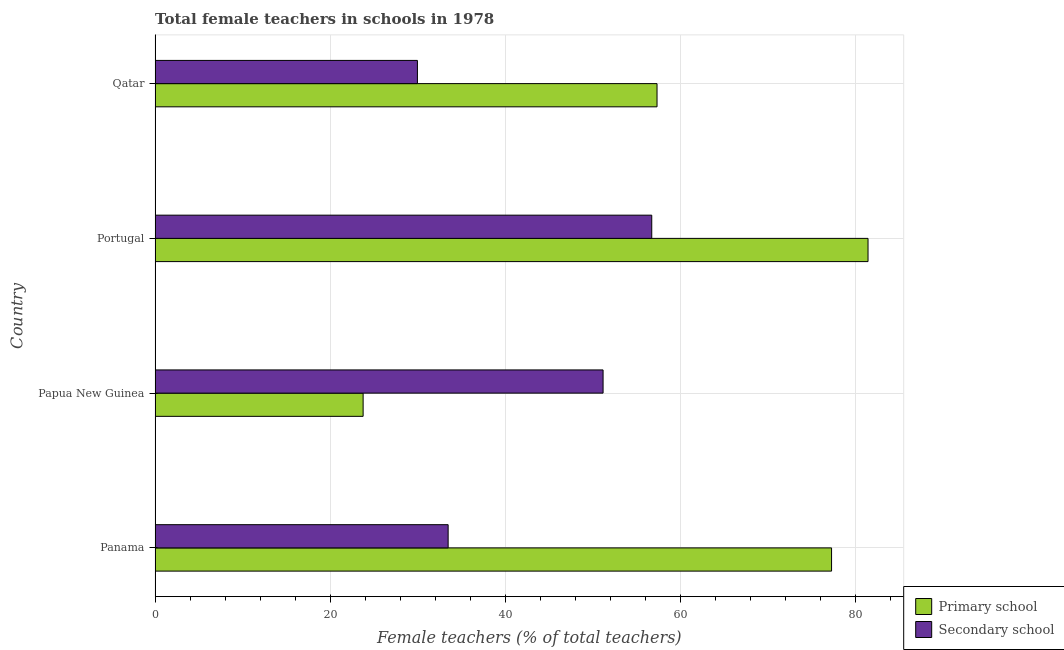How many different coloured bars are there?
Your answer should be very brief. 2. How many groups of bars are there?
Provide a succinct answer. 4. Are the number of bars per tick equal to the number of legend labels?
Ensure brevity in your answer.  Yes. How many bars are there on the 4th tick from the top?
Your answer should be compact. 2. How many bars are there on the 3rd tick from the bottom?
Give a very brief answer. 2. In how many cases, is the number of bars for a given country not equal to the number of legend labels?
Keep it short and to the point. 0. What is the percentage of female teachers in secondary schools in Qatar?
Your answer should be very brief. 29.96. Across all countries, what is the maximum percentage of female teachers in secondary schools?
Provide a succinct answer. 56.72. Across all countries, what is the minimum percentage of female teachers in primary schools?
Give a very brief answer. 23.76. In which country was the percentage of female teachers in primary schools minimum?
Keep it short and to the point. Papua New Guinea. What is the total percentage of female teachers in secondary schools in the graph?
Give a very brief answer. 171.32. What is the difference between the percentage of female teachers in primary schools in Papua New Guinea and that in Portugal?
Offer a very short reply. -57.66. What is the difference between the percentage of female teachers in secondary schools in Papua New Guinea and the percentage of female teachers in primary schools in Portugal?
Keep it short and to the point. -30.26. What is the average percentage of female teachers in primary schools per country?
Offer a very short reply. 59.94. What is the difference between the percentage of female teachers in secondary schools and percentage of female teachers in primary schools in Qatar?
Keep it short and to the point. -27.36. In how many countries, is the percentage of female teachers in secondary schools greater than 48 %?
Your answer should be very brief. 2. What is the ratio of the percentage of female teachers in secondary schools in Panama to that in Papua New Guinea?
Your answer should be very brief. 0.65. Is the difference between the percentage of female teachers in primary schools in Portugal and Qatar greater than the difference between the percentage of female teachers in secondary schools in Portugal and Qatar?
Make the answer very short. No. What is the difference between the highest and the second highest percentage of female teachers in secondary schools?
Make the answer very short. 5.56. What is the difference between the highest and the lowest percentage of female teachers in secondary schools?
Provide a succinct answer. 26.76. In how many countries, is the percentage of female teachers in secondary schools greater than the average percentage of female teachers in secondary schools taken over all countries?
Offer a very short reply. 2. Is the sum of the percentage of female teachers in secondary schools in Papua New Guinea and Qatar greater than the maximum percentage of female teachers in primary schools across all countries?
Ensure brevity in your answer.  No. What does the 2nd bar from the top in Panama represents?
Ensure brevity in your answer.  Primary school. What does the 2nd bar from the bottom in Qatar represents?
Ensure brevity in your answer.  Secondary school. Are all the bars in the graph horizontal?
Offer a very short reply. Yes. Are the values on the major ticks of X-axis written in scientific E-notation?
Make the answer very short. No. What is the title of the graph?
Your answer should be very brief. Total female teachers in schools in 1978. Does "Nitrous oxide" appear as one of the legend labels in the graph?
Keep it short and to the point. No. What is the label or title of the X-axis?
Keep it short and to the point. Female teachers (% of total teachers). What is the Female teachers (% of total teachers) of Primary school in Panama?
Provide a short and direct response. 77.26. What is the Female teachers (% of total teachers) of Secondary school in Panama?
Offer a terse response. 33.47. What is the Female teachers (% of total teachers) in Primary school in Papua New Guinea?
Your answer should be very brief. 23.76. What is the Female teachers (% of total teachers) in Secondary school in Papua New Guinea?
Offer a terse response. 51.16. What is the Female teachers (% of total teachers) of Primary school in Portugal?
Your response must be concise. 81.42. What is the Female teachers (% of total teachers) in Secondary school in Portugal?
Your response must be concise. 56.72. What is the Female teachers (% of total teachers) in Primary school in Qatar?
Keep it short and to the point. 57.32. What is the Female teachers (% of total teachers) of Secondary school in Qatar?
Give a very brief answer. 29.96. Across all countries, what is the maximum Female teachers (% of total teachers) of Primary school?
Offer a very short reply. 81.42. Across all countries, what is the maximum Female teachers (% of total teachers) in Secondary school?
Your answer should be compact. 56.72. Across all countries, what is the minimum Female teachers (% of total teachers) of Primary school?
Your answer should be very brief. 23.76. Across all countries, what is the minimum Female teachers (% of total teachers) of Secondary school?
Your answer should be compact. 29.96. What is the total Female teachers (% of total teachers) in Primary school in the graph?
Your answer should be compact. 239.76. What is the total Female teachers (% of total teachers) in Secondary school in the graph?
Make the answer very short. 171.32. What is the difference between the Female teachers (% of total teachers) of Primary school in Panama and that in Papua New Guinea?
Offer a terse response. 53.5. What is the difference between the Female teachers (% of total teachers) of Secondary school in Panama and that in Papua New Guinea?
Make the answer very short. -17.69. What is the difference between the Female teachers (% of total teachers) in Primary school in Panama and that in Portugal?
Make the answer very short. -4.16. What is the difference between the Female teachers (% of total teachers) of Secondary school in Panama and that in Portugal?
Your response must be concise. -23.25. What is the difference between the Female teachers (% of total teachers) of Primary school in Panama and that in Qatar?
Your response must be concise. 19.93. What is the difference between the Female teachers (% of total teachers) of Secondary school in Panama and that in Qatar?
Offer a very short reply. 3.51. What is the difference between the Female teachers (% of total teachers) in Primary school in Papua New Guinea and that in Portugal?
Provide a short and direct response. -57.66. What is the difference between the Female teachers (% of total teachers) of Secondary school in Papua New Guinea and that in Portugal?
Ensure brevity in your answer.  -5.56. What is the difference between the Female teachers (% of total teachers) in Primary school in Papua New Guinea and that in Qatar?
Give a very brief answer. -33.56. What is the difference between the Female teachers (% of total teachers) of Secondary school in Papua New Guinea and that in Qatar?
Offer a very short reply. 21.2. What is the difference between the Female teachers (% of total teachers) in Primary school in Portugal and that in Qatar?
Provide a succinct answer. 24.1. What is the difference between the Female teachers (% of total teachers) in Secondary school in Portugal and that in Qatar?
Give a very brief answer. 26.76. What is the difference between the Female teachers (% of total teachers) in Primary school in Panama and the Female teachers (% of total teachers) in Secondary school in Papua New Guinea?
Your answer should be compact. 26.09. What is the difference between the Female teachers (% of total teachers) of Primary school in Panama and the Female teachers (% of total teachers) of Secondary school in Portugal?
Provide a short and direct response. 20.53. What is the difference between the Female teachers (% of total teachers) in Primary school in Panama and the Female teachers (% of total teachers) in Secondary school in Qatar?
Your response must be concise. 47.29. What is the difference between the Female teachers (% of total teachers) of Primary school in Papua New Guinea and the Female teachers (% of total teachers) of Secondary school in Portugal?
Keep it short and to the point. -32.96. What is the difference between the Female teachers (% of total teachers) in Primary school in Papua New Guinea and the Female teachers (% of total teachers) in Secondary school in Qatar?
Keep it short and to the point. -6.2. What is the difference between the Female teachers (% of total teachers) of Primary school in Portugal and the Female teachers (% of total teachers) of Secondary school in Qatar?
Offer a very short reply. 51.46. What is the average Female teachers (% of total teachers) in Primary school per country?
Give a very brief answer. 59.94. What is the average Female teachers (% of total teachers) in Secondary school per country?
Your answer should be very brief. 42.83. What is the difference between the Female teachers (% of total teachers) of Primary school and Female teachers (% of total teachers) of Secondary school in Panama?
Your response must be concise. 43.79. What is the difference between the Female teachers (% of total teachers) in Primary school and Female teachers (% of total teachers) in Secondary school in Papua New Guinea?
Offer a terse response. -27.4. What is the difference between the Female teachers (% of total teachers) of Primary school and Female teachers (% of total teachers) of Secondary school in Portugal?
Make the answer very short. 24.7. What is the difference between the Female teachers (% of total teachers) in Primary school and Female teachers (% of total teachers) in Secondary school in Qatar?
Give a very brief answer. 27.36. What is the ratio of the Female teachers (% of total teachers) of Primary school in Panama to that in Papua New Guinea?
Your response must be concise. 3.25. What is the ratio of the Female teachers (% of total teachers) in Secondary school in Panama to that in Papua New Guinea?
Provide a short and direct response. 0.65. What is the ratio of the Female teachers (% of total teachers) in Primary school in Panama to that in Portugal?
Keep it short and to the point. 0.95. What is the ratio of the Female teachers (% of total teachers) of Secondary school in Panama to that in Portugal?
Provide a short and direct response. 0.59. What is the ratio of the Female teachers (% of total teachers) of Primary school in Panama to that in Qatar?
Keep it short and to the point. 1.35. What is the ratio of the Female teachers (% of total teachers) in Secondary school in Panama to that in Qatar?
Offer a very short reply. 1.12. What is the ratio of the Female teachers (% of total teachers) of Primary school in Papua New Guinea to that in Portugal?
Make the answer very short. 0.29. What is the ratio of the Female teachers (% of total teachers) in Secondary school in Papua New Guinea to that in Portugal?
Provide a succinct answer. 0.9. What is the ratio of the Female teachers (% of total teachers) of Primary school in Papua New Guinea to that in Qatar?
Offer a very short reply. 0.41. What is the ratio of the Female teachers (% of total teachers) of Secondary school in Papua New Guinea to that in Qatar?
Your answer should be compact. 1.71. What is the ratio of the Female teachers (% of total teachers) in Primary school in Portugal to that in Qatar?
Provide a short and direct response. 1.42. What is the ratio of the Female teachers (% of total teachers) in Secondary school in Portugal to that in Qatar?
Provide a short and direct response. 1.89. What is the difference between the highest and the second highest Female teachers (% of total teachers) of Primary school?
Make the answer very short. 4.16. What is the difference between the highest and the second highest Female teachers (% of total teachers) in Secondary school?
Ensure brevity in your answer.  5.56. What is the difference between the highest and the lowest Female teachers (% of total teachers) of Primary school?
Your answer should be compact. 57.66. What is the difference between the highest and the lowest Female teachers (% of total teachers) of Secondary school?
Make the answer very short. 26.76. 